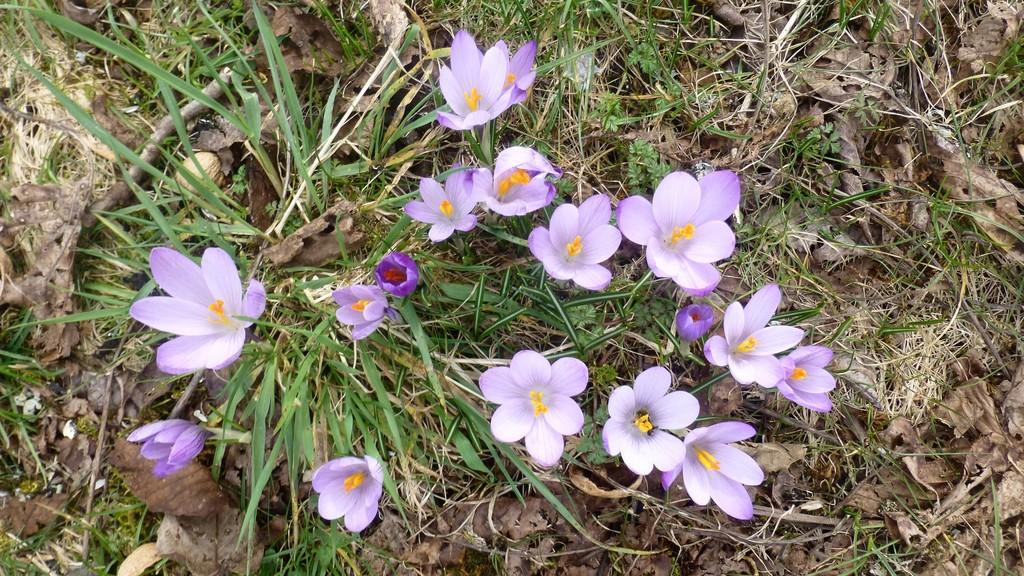What color are the flowers in the image? The flowers in the image are violet. What else can be seen on the ground in the image? Dry leaves are present in the image. What type of vegetation is visible on the ground in the image? There is grass on the ground in the image. What type of design can be seen on the net in the image? There is no net present in the image; it only features violet flowers, dry leaves, and grass. 